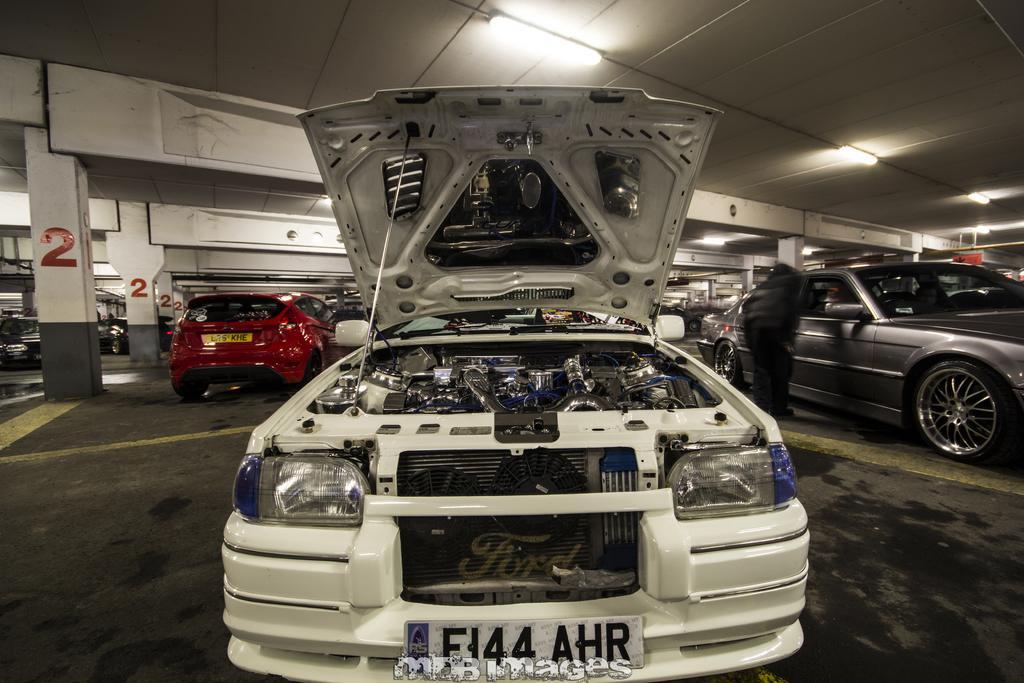In one or two sentences, can you explain what this image depicts? In this image we can see group of vehicles parked on the ground. On the right side of the image we can see a person standing on the ground. In the background, we can see a group of pillars with numbers, some lights and poles. At the bottom we can see some text. 